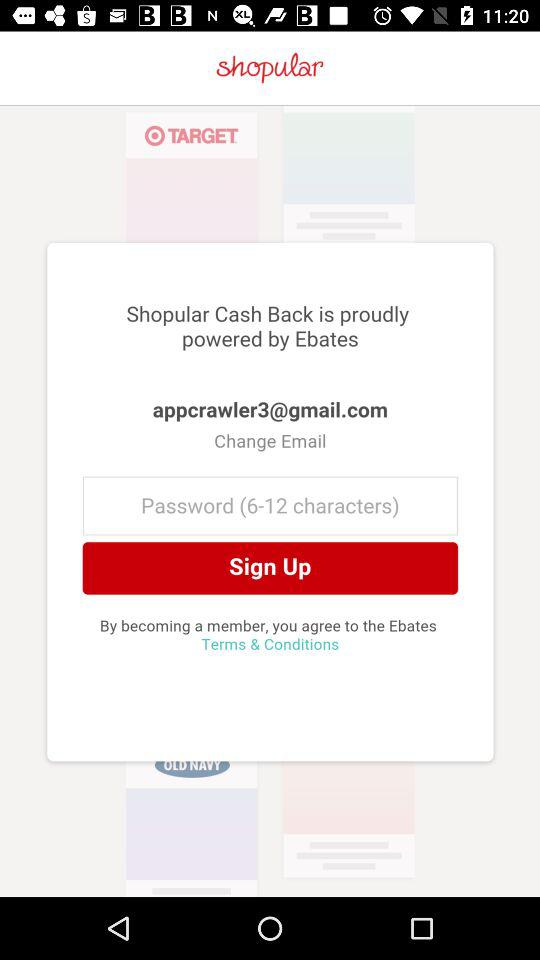What is the email address? The email address is appcrawler3@gmail.com. 